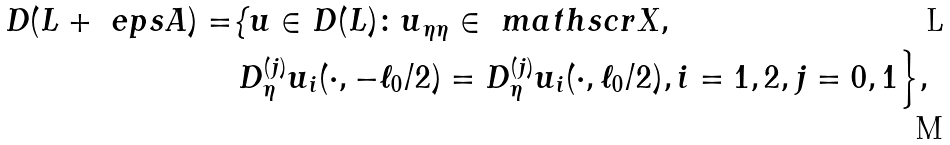<formula> <loc_0><loc_0><loc_500><loc_500>D ( L + \ e p s A ) = & \{ { u } \in D ( L ) \colon { u } _ { \eta \eta } \in { \ m a t h s c r X } , \\ & \, D ^ { ( j ) } _ { \eta } u _ { i } ( \cdot , - \ell _ { 0 } / 2 ) = D ^ { ( j ) } _ { \eta } u _ { i } ( \cdot , \ell _ { 0 } / 2 ) , i = 1 , 2 , j = 0 , 1 \Big \} ,</formula> 